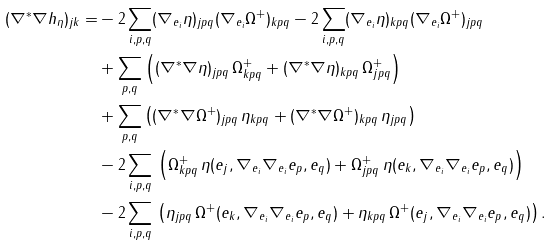<formula> <loc_0><loc_0><loc_500><loc_500>( \nabla ^ { * } \nabla h _ { \eta } ) _ { j k } = & - 2 \sum _ { i , p , q } ( \nabla _ { e _ { i } } \eta ) _ { j p q } ( \nabla _ { e _ { i } } \Omega ^ { + } ) _ { k p q } - 2 \sum _ { i , p , q } ( \nabla _ { e _ { i } } \eta ) _ { k p q } ( \nabla _ { e _ { i } } \Omega ^ { + } ) _ { j p q } \\ & + \sum _ { p , q } \left ( ( \nabla ^ { * } \nabla \eta ) _ { j p q } \, \Omega ^ { + } _ { k p q } + ( \nabla ^ { * } \nabla \eta ) _ { k p q } \, \Omega ^ { + } _ { j p q } \right ) \\ & + \sum _ { p , q } \left ( ( \nabla ^ { * } \nabla \Omega ^ { + } ) _ { j p q } \, \eta _ { k p q } + ( \nabla ^ { * } \nabla \Omega ^ { + } ) _ { k p q } \, \eta _ { j p q } \right ) \\ & - 2 \sum _ { i , p , q } \, \left ( \Omega ^ { + } _ { k p q } \, \eta ( e _ { j } , \nabla _ { e _ { i } } \nabla _ { e _ { i } } e _ { p } , e _ { q } ) + \Omega ^ { + } _ { j p q } \, \eta ( e _ { k } , \nabla _ { e _ { i } } \nabla _ { e _ { i } } e _ { p } , e _ { q } ) \right ) \\ & - 2 \sum _ { i , p , q } \, \left ( \eta _ { j p q } \, \Omega ^ { + } ( e _ { k } , \nabla _ { e _ { i } } \nabla _ { e _ { i } } e _ { p } , e _ { q } ) + \eta _ { k p q } \, \Omega ^ { + } ( e _ { j } , \nabla _ { e _ { i } } \nabla _ { e _ { i } } e _ { p } , e _ { q } ) \right ) .</formula> 